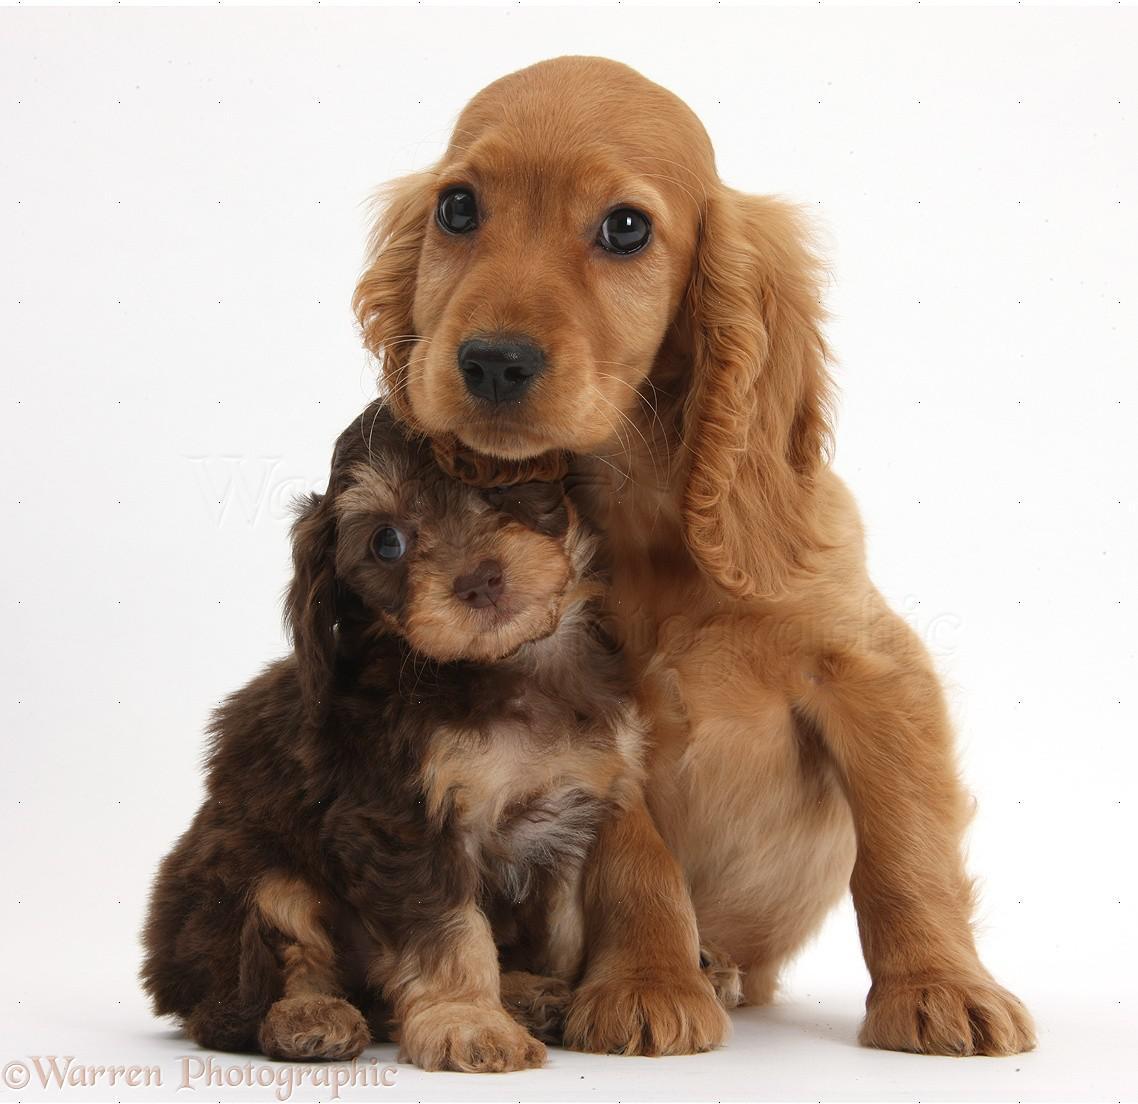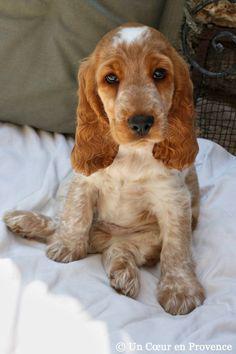The first image is the image on the left, the second image is the image on the right. Assess this claim about the two images: "A dog is sitting with a dog of another species in the image on the left.". Correct or not? Answer yes or no. No. 